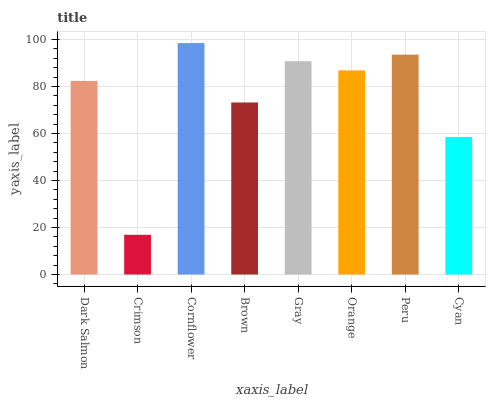Is Crimson the minimum?
Answer yes or no. Yes. Is Cornflower the maximum?
Answer yes or no. Yes. Is Cornflower the minimum?
Answer yes or no. No. Is Crimson the maximum?
Answer yes or no. No. Is Cornflower greater than Crimson?
Answer yes or no. Yes. Is Crimson less than Cornflower?
Answer yes or no. Yes. Is Crimson greater than Cornflower?
Answer yes or no. No. Is Cornflower less than Crimson?
Answer yes or no. No. Is Orange the high median?
Answer yes or no. Yes. Is Dark Salmon the low median?
Answer yes or no. Yes. Is Cornflower the high median?
Answer yes or no. No. Is Brown the low median?
Answer yes or no. No. 